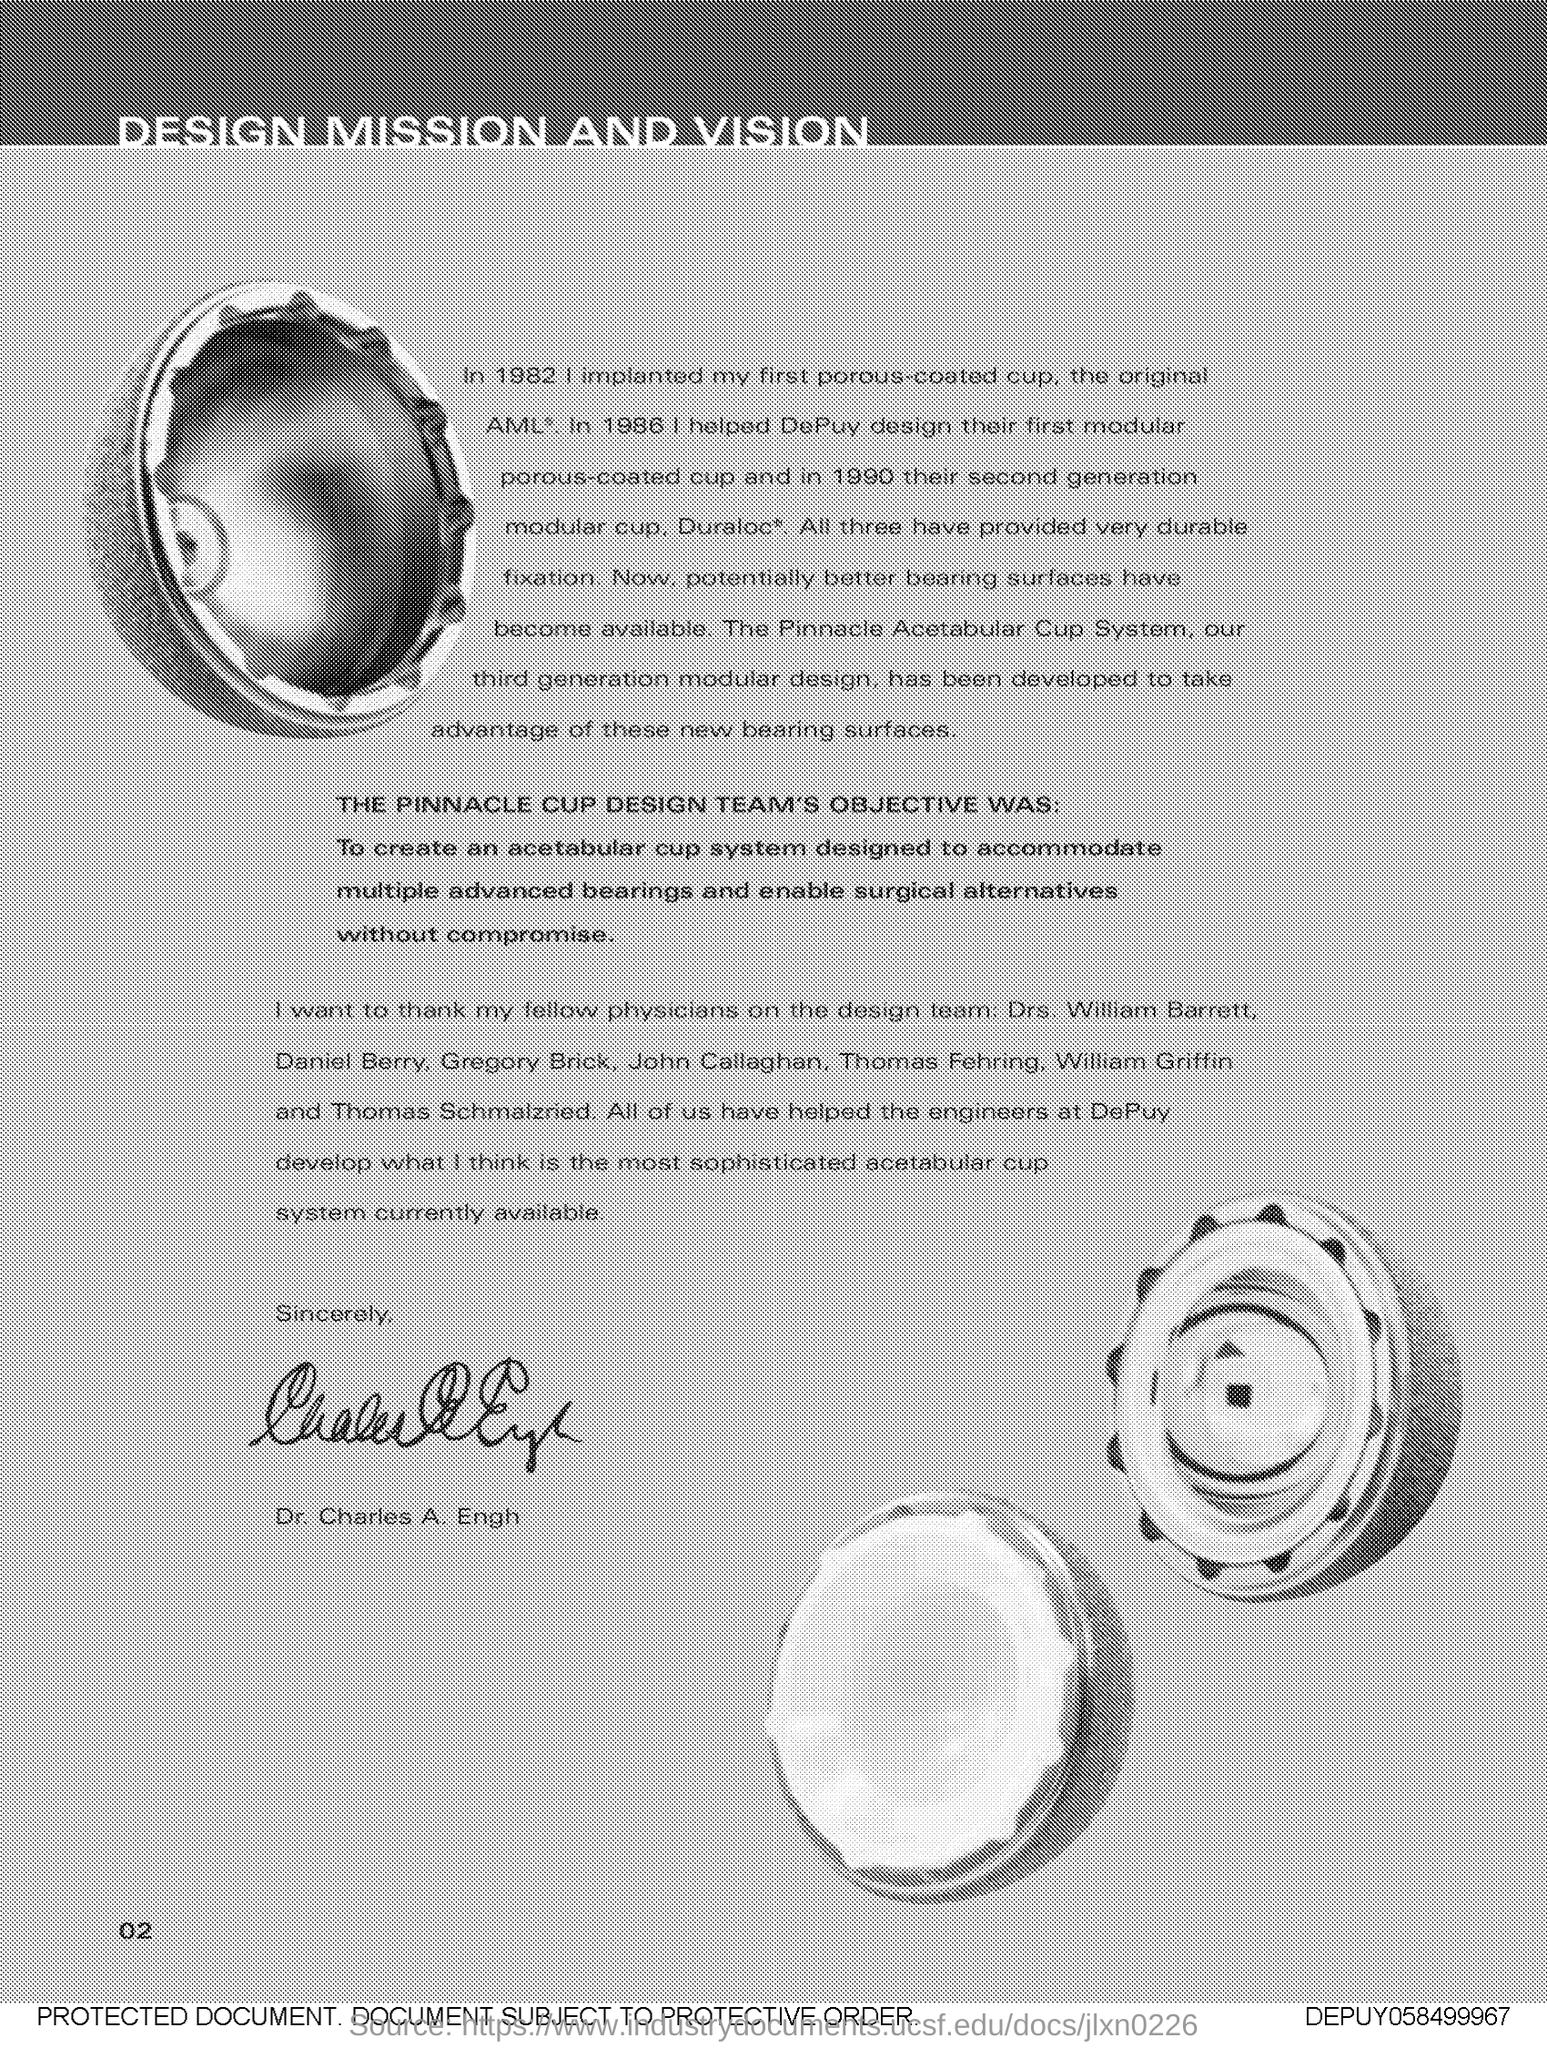What is the number at bottom left side of the page ?
Provide a succinct answer. 02. 